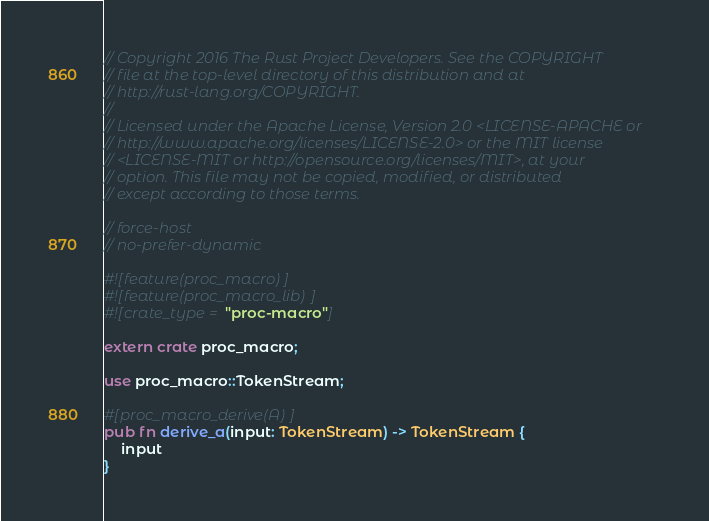<code> <loc_0><loc_0><loc_500><loc_500><_Rust_>// Copyright 2016 The Rust Project Developers. See the COPYRIGHT
// file at the top-level directory of this distribution and at
// http://rust-lang.org/COPYRIGHT.
//
// Licensed under the Apache License, Version 2.0 <LICENSE-APACHE or
// http://www.apache.org/licenses/LICENSE-2.0> or the MIT license
// <LICENSE-MIT or http://opensource.org/licenses/MIT>, at your
// option. This file may not be copied, modified, or distributed
// except according to those terms.

// force-host
// no-prefer-dynamic

#![feature(proc_macro)]
#![feature(proc_macro_lib)]
#![crate_type = "proc-macro"]

extern crate proc_macro;

use proc_macro::TokenStream;

#[proc_macro_derive(A)]
pub fn derive_a(input: TokenStream) -> TokenStream {
    input
}
</code> 